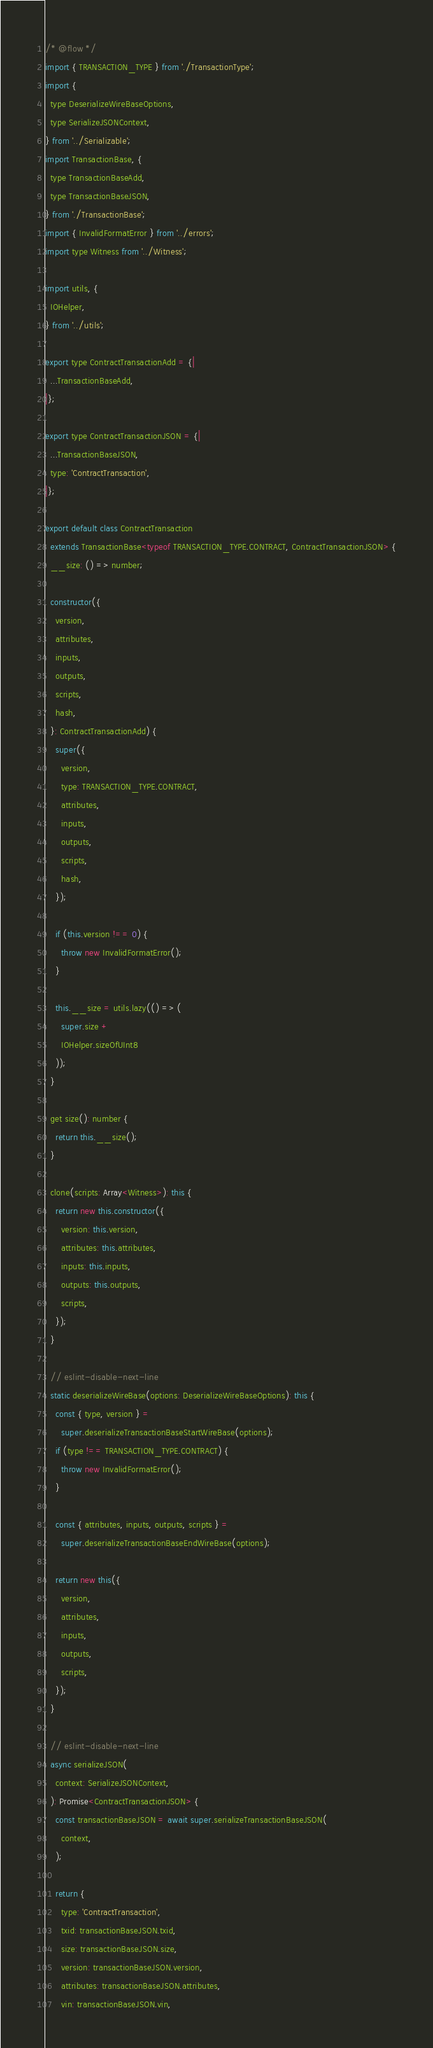Convert code to text. <code><loc_0><loc_0><loc_500><loc_500><_JavaScript_>/* @flow */
import { TRANSACTION_TYPE } from './TransactionType';
import {
  type DeserializeWireBaseOptions,
  type SerializeJSONContext,
} from '../Serializable';
import TransactionBase, {
  type TransactionBaseAdd,
  type TransactionBaseJSON,
} from './TransactionBase';
import { InvalidFormatError } from '../errors';
import type Witness from '../Witness';

import utils, {
  IOHelper,
} from '../utils';

export type ContractTransactionAdd = {|
  ...TransactionBaseAdd,
|};

export type ContractTransactionJSON = {|
  ...TransactionBaseJSON,
  type: 'ContractTransaction',
|};

export default class ContractTransaction
  extends TransactionBase<typeof TRANSACTION_TYPE.CONTRACT, ContractTransactionJSON> {
  __size: () => number;

  constructor({
    version,
    attributes,
    inputs,
    outputs,
    scripts,
    hash,
  }: ContractTransactionAdd) {
    super({
      version,
      type: TRANSACTION_TYPE.CONTRACT,
      attributes,
      inputs,
      outputs,
      scripts,
      hash,
    });

    if (this.version !== 0) {
      throw new InvalidFormatError();
    }

    this.__size = utils.lazy(() => (
      super.size +
      IOHelper.sizeOfUInt8
    ));
  }

  get size(): number {
    return this.__size();
  }

  clone(scripts: Array<Witness>): this {
    return new this.constructor({
      version: this.version,
      attributes: this.attributes,
      inputs: this.inputs,
      outputs: this.outputs,
      scripts,
    });
  }

  // eslint-disable-next-line
  static deserializeWireBase(options: DeserializeWireBaseOptions): this {
    const { type, version } =
      super.deserializeTransactionBaseStartWireBase(options);
    if (type !== TRANSACTION_TYPE.CONTRACT) {
      throw new InvalidFormatError();
    }

    const { attributes, inputs, outputs, scripts } =
      super.deserializeTransactionBaseEndWireBase(options);

    return new this({
      version,
      attributes,
      inputs,
      outputs,
      scripts,
    });
  }

  // eslint-disable-next-line
  async serializeJSON(
    context: SerializeJSONContext,
  ): Promise<ContractTransactionJSON> {
    const transactionBaseJSON = await super.serializeTransactionBaseJSON(
      context,
    );

    return {
      type: 'ContractTransaction',
      txid: transactionBaseJSON.txid,
      size: transactionBaseJSON.size,
      version: transactionBaseJSON.version,
      attributes: transactionBaseJSON.attributes,
      vin: transactionBaseJSON.vin,</code> 